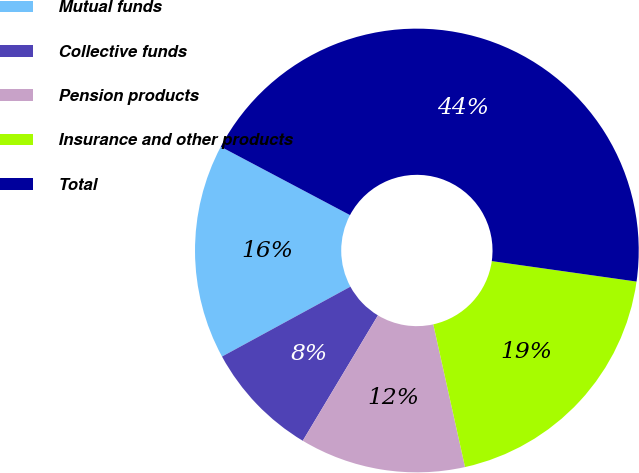Convert chart to OTSL. <chart><loc_0><loc_0><loc_500><loc_500><pie_chart><fcel>Mutual funds<fcel>Collective funds<fcel>Pension products<fcel>Insurance and other products<fcel>Total<nl><fcel>15.68%<fcel>8.47%<fcel>12.08%<fcel>19.28%<fcel>44.49%<nl></chart> 